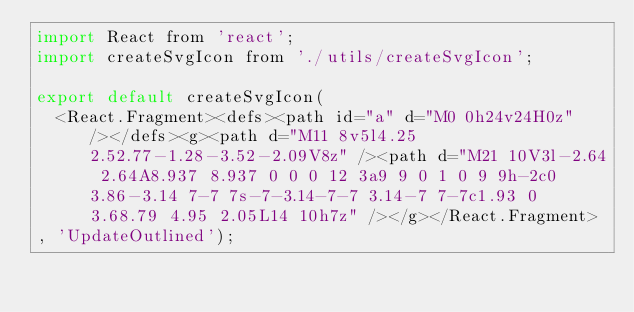Convert code to text. <code><loc_0><loc_0><loc_500><loc_500><_JavaScript_>import React from 'react';
import createSvgIcon from './utils/createSvgIcon';

export default createSvgIcon(
  <React.Fragment><defs><path id="a" d="M0 0h24v24H0z" /></defs><g><path d="M11 8v5l4.25 2.52.77-1.28-3.52-2.09V8z" /><path d="M21 10V3l-2.64 2.64A8.937 8.937 0 0 0 12 3a9 9 0 1 0 9 9h-2c0 3.86-3.14 7-7 7s-7-3.14-7-7 3.14-7 7-7c1.93 0 3.68.79 4.95 2.05L14 10h7z" /></g></React.Fragment>
, 'UpdateOutlined');
</code> 